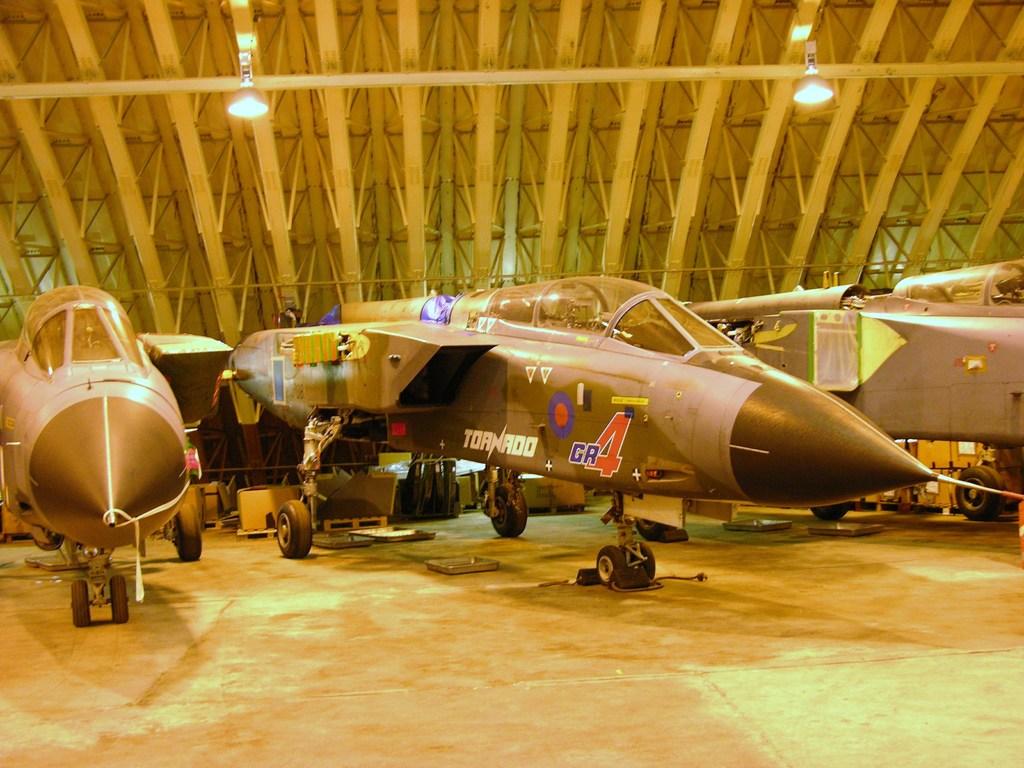What is the word in white?
Provide a short and direct response. Tornado. What number is in red?
Offer a very short reply. 4. 